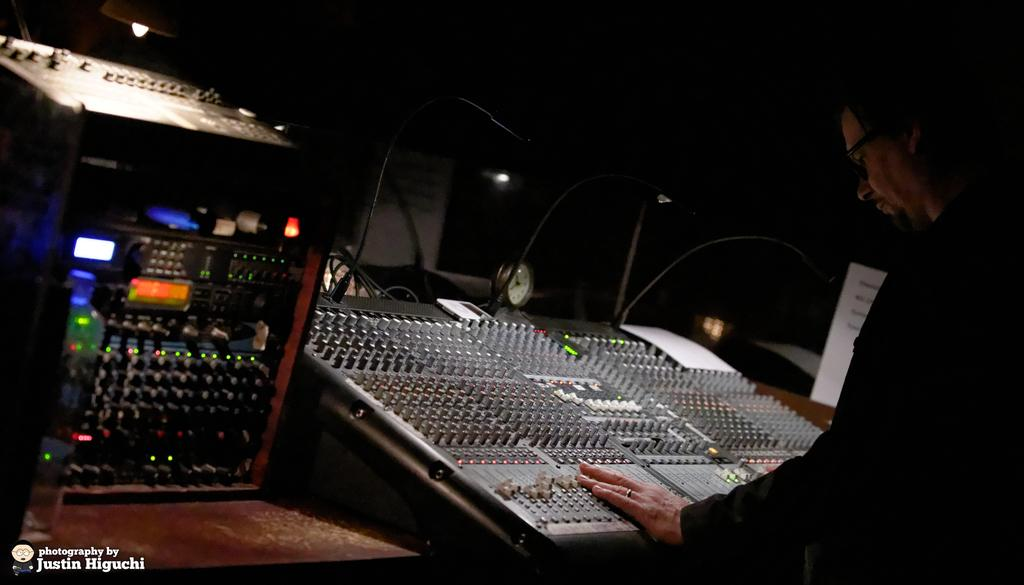What is happening in the image? There is a person in the image who is operating an electronic device. Can you describe the electronic device being operated? Unfortunately, the specific details of the electronic device being operated are not provided in the facts. Are there any other electronic devices visible in the image? Yes, there is another electronic device beside the one being operated. What angle is the person's body at while operating the electronic device? The angle of the person's body is not mentioned in the facts, and therefore cannot be determined from the image. 